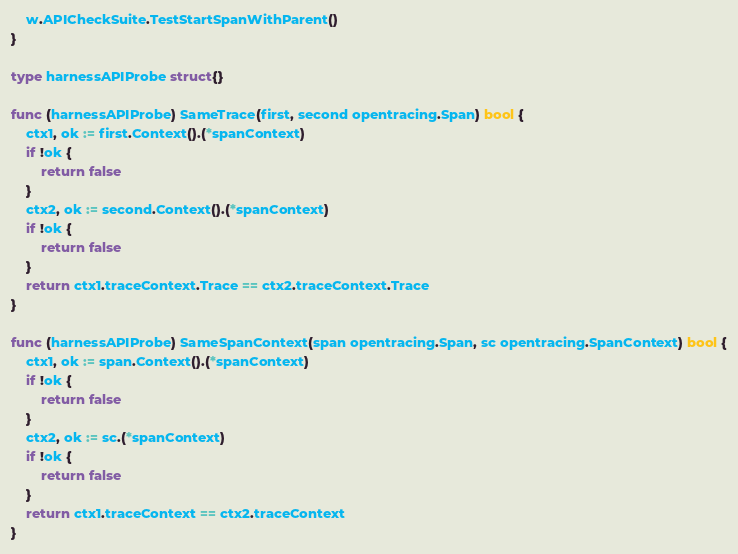Convert code to text. <code><loc_0><loc_0><loc_500><loc_500><_Go_>	w.APICheckSuite.TestStartSpanWithParent()
}

type harnessAPIProbe struct{}

func (harnessAPIProbe) SameTrace(first, second opentracing.Span) bool {
	ctx1, ok := first.Context().(*spanContext)
	if !ok {
		return false
	}
	ctx2, ok := second.Context().(*spanContext)
	if !ok {
		return false
	}
	return ctx1.traceContext.Trace == ctx2.traceContext.Trace
}

func (harnessAPIProbe) SameSpanContext(span opentracing.Span, sc opentracing.SpanContext) bool {
	ctx1, ok := span.Context().(*spanContext)
	if !ok {
		return false
	}
	ctx2, ok := sc.(*spanContext)
	if !ok {
		return false
	}
	return ctx1.traceContext == ctx2.traceContext
}
</code> 